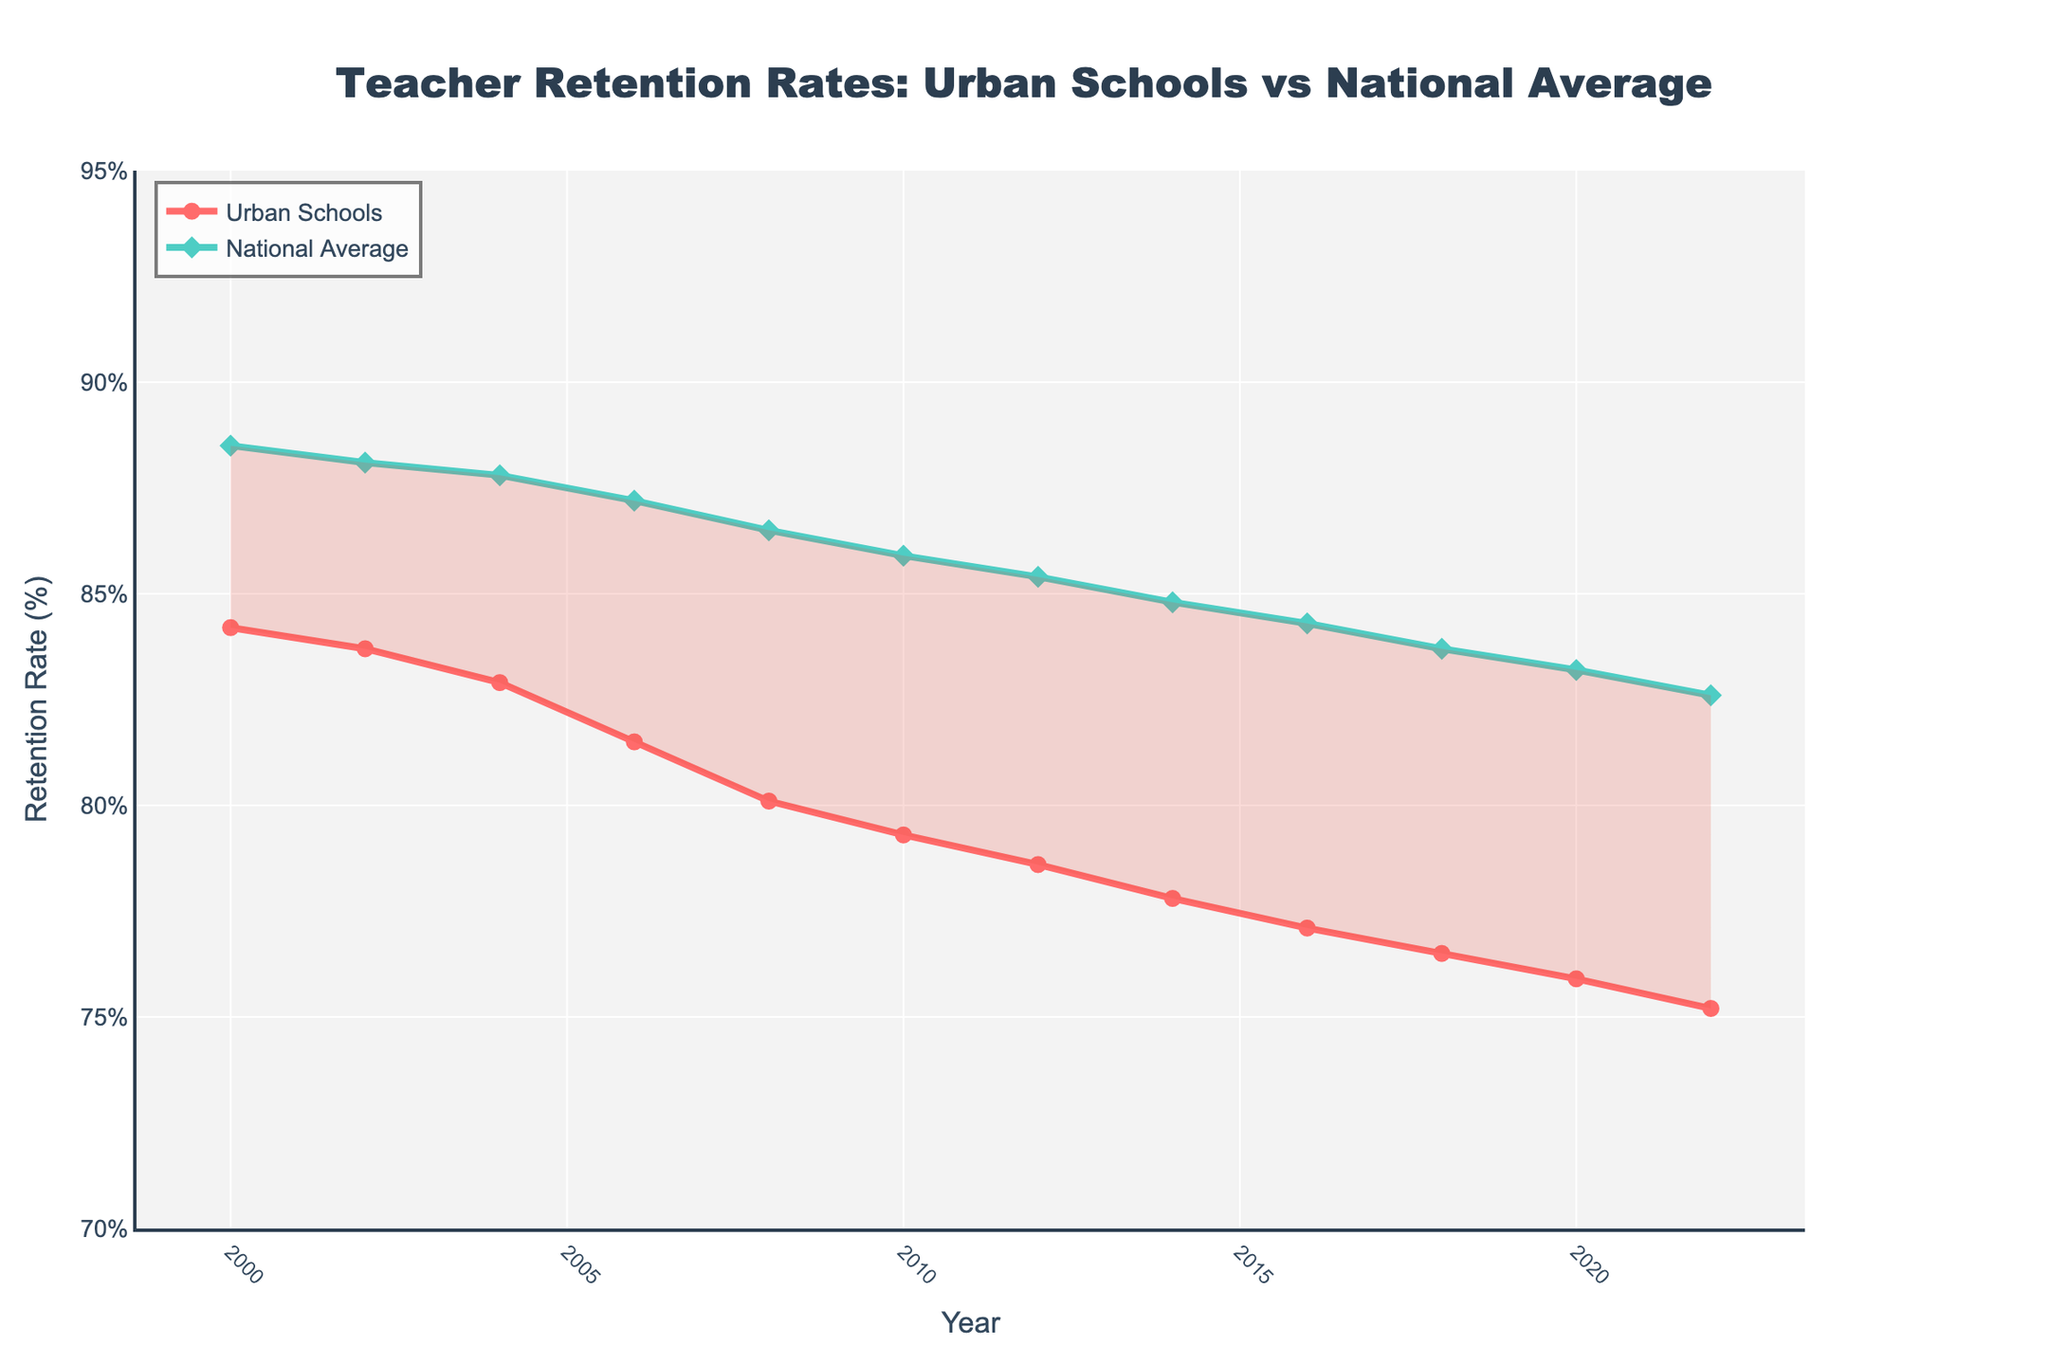What year did the retention rate in urban schools drop below 80%? By examining the line representing the Urban Schools Retention Rate, we can see it dips below 80% between 2008 and 2010, indicating that it first went below 80% in 2010.
Answer: 2010 How much has the retention rate in urban schools declined from 2000 to 2022? The retention rate in urban schools was 84.2% in 2000 and 75.2% in 2022. The decline is calculated as 84.2% - 75.2% = 9%.
Answer: 9% What is the difference between urban schools and the national average retention rates in 2022? The Urban Schools Retention Rate in 2022 is 75.2%, while the National Average Retention Rate is 82.6%. The difference is 82.6% - 75.2% = 7.4%.
Answer: 7.4% Which year shows the closest retention rates between urban schools and the national average? By examining the gap between the two lines in the chart, we see that the smallest gap is in 2022, where urban schools have a retention rate of 75.2% and the national average is 82.6%, making the difference 7.4%.
Answer: 2022 In which period did urban schools experience the steepest decline in retention rate? By examining the slope of the line representing the Urban Schools Retention Rate, the steepest decline occurs between 2006 and 2010, with the rate dropping from 81.5% to 79.3%, a difference of 2.2%.
Answer: 2006-2010 How many years show urban schools retention rate above 80%? Urban Schools Retention Rate was above 80% in the years 2000, 2002, 2004, 2006, and 2008, making it a total of 5 years.
Answer: 5 years During which years was the retention rate gap between urban schools and the national average less than 5%? To find this, we need to calculate the difference for each year. The retention rate gap is less than 5% in the following years: 2000 (4.3%), and 2002 (4.4%).
Answer: 2000, 2002 What was the average retention rate in urban schools from 2000 to 2022? Sum the retention rates for each year and divide by the number of years (12): (84.2 + 83.7 + 82.9 + 81.5 + 80.1 + 79.3 + 78.6 + 77.8 + 77.1 + 76.5 + 75.9 + 75.2) / 12 = 79.16%.
Answer: 79.16% Which year had the highest national average retention rate and what was the rate? By examining the line representing the National Average Retention Rate, we see that the highest rate was in 2000, at 88.5%.
Answer: 2000, 88.5% How does the retention rate trend in urban schools compare to the national average from 2000 to 2022? Both trends show a declining pattern. Urban schools start at a higher retention rate compared to the national average but drop more steeply over the years, resulting in a larger gap by 2022.
Answer: Declining 